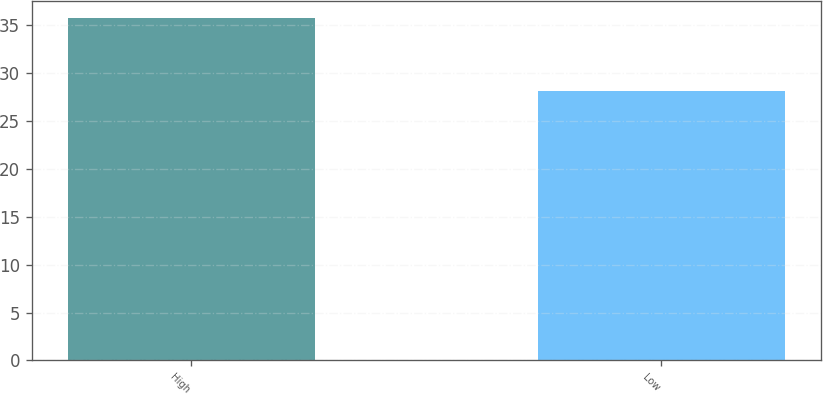Convert chart to OTSL. <chart><loc_0><loc_0><loc_500><loc_500><bar_chart><fcel>High<fcel>Low<nl><fcel>35.8<fcel>28.18<nl></chart> 